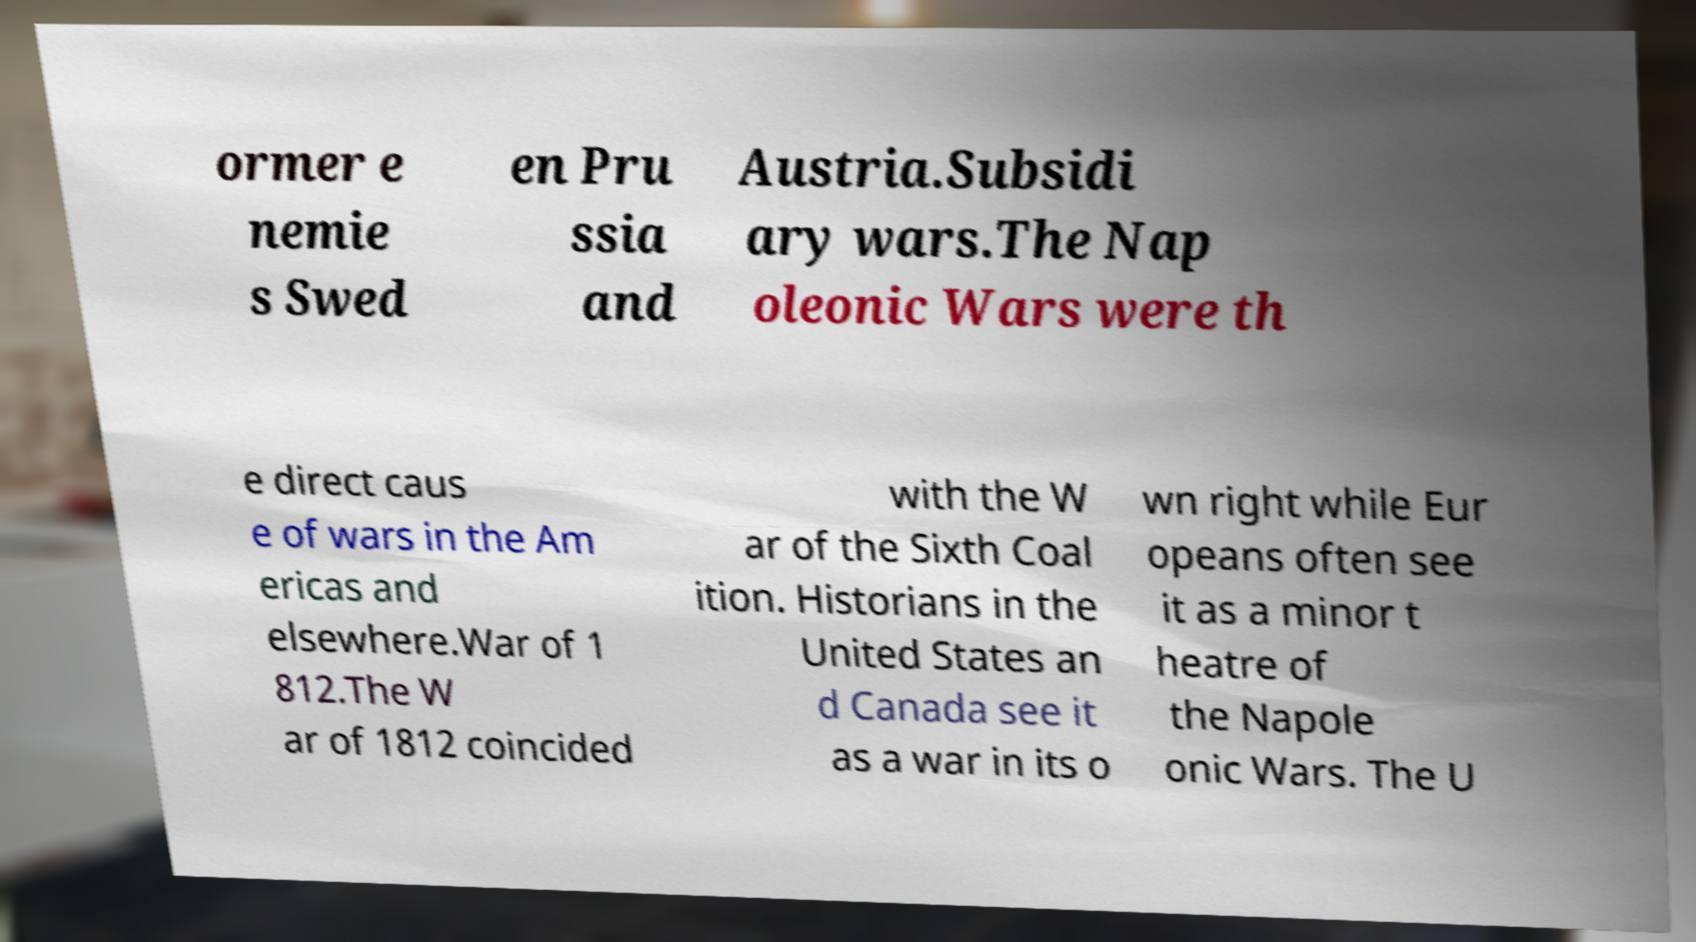There's text embedded in this image that I need extracted. Can you transcribe it verbatim? ormer e nemie s Swed en Pru ssia and Austria.Subsidi ary wars.The Nap oleonic Wars were th e direct caus e of wars in the Am ericas and elsewhere.War of 1 812.The W ar of 1812 coincided with the W ar of the Sixth Coal ition. Historians in the United States an d Canada see it as a war in its o wn right while Eur opeans often see it as a minor t heatre of the Napole onic Wars. The U 